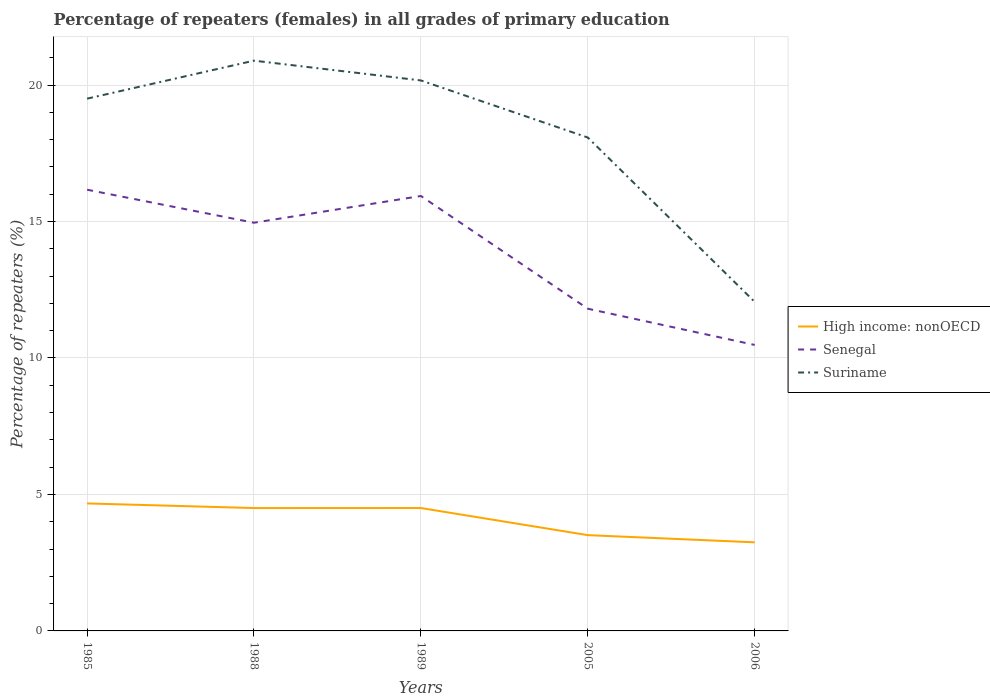How many different coloured lines are there?
Give a very brief answer. 3. Is the number of lines equal to the number of legend labels?
Make the answer very short. Yes. Across all years, what is the maximum percentage of repeaters (females) in Suriname?
Offer a terse response. 12.06. What is the total percentage of repeaters (females) in Senegal in the graph?
Provide a short and direct response. 0.23. What is the difference between the highest and the second highest percentage of repeaters (females) in High income: nonOECD?
Make the answer very short. 1.42. Is the percentage of repeaters (females) in Senegal strictly greater than the percentage of repeaters (females) in High income: nonOECD over the years?
Your response must be concise. No. How many lines are there?
Offer a very short reply. 3. How many years are there in the graph?
Your response must be concise. 5. What is the difference between two consecutive major ticks on the Y-axis?
Your response must be concise. 5. Are the values on the major ticks of Y-axis written in scientific E-notation?
Your response must be concise. No. How are the legend labels stacked?
Give a very brief answer. Vertical. What is the title of the graph?
Your answer should be compact. Percentage of repeaters (females) in all grades of primary education. Does "Belgium" appear as one of the legend labels in the graph?
Make the answer very short. No. What is the label or title of the Y-axis?
Your answer should be compact. Percentage of repeaters (%). What is the Percentage of repeaters (%) in High income: nonOECD in 1985?
Ensure brevity in your answer.  4.67. What is the Percentage of repeaters (%) of Senegal in 1985?
Keep it short and to the point. 16.17. What is the Percentage of repeaters (%) of Suriname in 1985?
Provide a short and direct response. 19.5. What is the Percentage of repeaters (%) of High income: nonOECD in 1988?
Offer a terse response. 4.5. What is the Percentage of repeaters (%) of Senegal in 1988?
Keep it short and to the point. 14.96. What is the Percentage of repeaters (%) in Suriname in 1988?
Provide a succinct answer. 20.89. What is the Percentage of repeaters (%) of High income: nonOECD in 1989?
Provide a short and direct response. 4.5. What is the Percentage of repeaters (%) of Senegal in 1989?
Keep it short and to the point. 15.94. What is the Percentage of repeaters (%) of Suriname in 1989?
Give a very brief answer. 20.17. What is the Percentage of repeaters (%) of High income: nonOECD in 2005?
Keep it short and to the point. 3.51. What is the Percentage of repeaters (%) of Senegal in 2005?
Ensure brevity in your answer.  11.81. What is the Percentage of repeaters (%) of Suriname in 2005?
Your answer should be very brief. 18.08. What is the Percentage of repeaters (%) in High income: nonOECD in 2006?
Give a very brief answer. 3.25. What is the Percentage of repeaters (%) in Senegal in 2006?
Offer a very short reply. 10.48. What is the Percentage of repeaters (%) in Suriname in 2006?
Provide a short and direct response. 12.06. Across all years, what is the maximum Percentage of repeaters (%) in High income: nonOECD?
Your answer should be compact. 4.67. Across all years, what is the maximum Percentage of repeaters (%) in Senegal?
Your response must be concise. 16.17. Across all years, what is the maximum Percentage of repeaters (%) in Suriname?
Your answer should be compact. 20.89. Across all years, what is the minimum Percentage of repeaters (%) of High income: nonOECD?
Your response must be concise. 3.25. Across all years, what is the minimum Percentage of repeaters (%) in Senegal?
Your answer should be very brief. 10.48. Across all years, what is the minimum Percentage of repeaters (%) in Suriname?
Provide a succinct answer. 12.06. What is the total Percentage of repeaters (%) in High income: nonOECD in the graph?
Offer a terse response. 20.43. What is the total Percentage of repeaters (%) of Senegal in the graph?
Make the answer very short. 69.34. What is the total Percentage of repeaters (%) of Suriname in the graph?
Your answer should be very brief. 90.7. What is the difference between the Percentage of repeaters (%) in High income: nonOECD in 1985 and that in 1988?
Provide a succinct answer. 0.17. What is the difference between the Percentage of repeaters (%) in Senegal in 1985 and that in 1988?
Your answer should be compact. 1.21. What is the difference between the Percentage of repeaters (%) of Suriname in 1985 and that in 1988?
Ensure brevity in your answer.  -1.39. What is the difference between the Percentage of repeaters (%) of High income: nonOECD in 1985 and that in 1989?
Your answer should be compact. 0.17. What is the difference between the Percentage of repeaters (%) in Senegal in 1985 and that in 1989?
Give a very brief answer. 0.23. What is the difference between the Percentage of repeaters (%) in Suriname in 1985 and that in 1989?
Provide a succinct answer. -0.67. What is the difference between the Percentage of repeaters (%) in High income: nonOECD in 1985 and that in 2005?
Offer a very short reply. 1.16. What is the difference between the Percentage of repeaters (%) of Senegal in 1985 and that in 2005?
Give a very brief answer. 4.36. What is the difference between the Percentage of repeaters (%) of Suriname in 1985 and that in 2005?
Provide a succinct answer. 1.42. What is the difference between the Percentage of repeaters (%) of High income: nonOECD in 1985 and that in 2006?
Make the answer very short. 1.42. What is the difference between the Percentage of repeaters (%) in Senegal in 1985 and that in 2006?
Make the answer very short. 5.69. What is the difference between the Percentage of repeaters (%) in Suriname in 1985 and that in 2006?
Offer a very short reply. 7.45. What is the difference between the Percentage of repeaters (%) of High income: nonOECD in 1988 and that in 1989?
Offer a terse response. -0. What is the difference between the Percentage of repeaters (%) of Senegal in 1988 and that in 1989?
Your answer should be compact. -0.98. What is the difference between the Percentage of repeaters (%) in Suriname in 1988 and that in 1989?
Give a very brief answer. 0.72. What is the difference between the Percentage of repeaters (%) in High income: nonOECD in 1988 and that in 2005?
Offer a very short reply. 0.99. What is the difference between the Percentage of repeaters (%) of Senegal in 1988 and that in 2005?
Offer a very short reply. 3.15. What is the difference between the Percentage of repeaters (%) of Suriname in 1988 and that in 2005?
Provide a short and direct response. 2.82. What is the difference between the Percentage of repeaters (%) in High income: nonOECD in 1988 and that in 2006?
Give a very brief answer. 1.26. What is the difference between the Percentage of repeaters (%) in Senegal in 1988 and that in 2006?
Provide a short and direct response. 4.48. What is the difference between the Percentage of repeaters (%) in Suriname in 1988 and that in 2006?
Provide a succinct answer. 8.84. What is the difference between the Percentage of repeaters (%) in High income: nonOECD in 1989 and that in 2005?
Offer a very short reply. 0.99. What is the difference between the Percentage of repeaters (%) in Senegal in 1989 and that in 2005?
Your response must be concise. 4.13. What is the difference between the Percentage of repeaters (%) of Suriname in 1989 and that in 2005?
Offer a terse response. 2.09. What is the difference between the Percentage of repeaters (%) in High income: nonOECD in 1989 and that in 2006?
Ensure brevity in your answer.  1.26. What is the difference between the Percentage of repeaters (%) of Senegal in 1989 and that in 2006?
Ensure brevity in your answer.  5.46. What is the difference between the Percentage of repeaters (%) of Suriname in 1989 and that in 2006?
Your response must be concise. 8.11. What is the difference between the Percentage of repeaters (%) of High income: nonOECD in 2005 and that in 2006?
Provide a short and direct response. 0.26. What is the difference between the Percentage of repeaters (%) in Senegal in 2005 and that in 2006?
Ensure brevity in your answer.  1.33. What is the difference between the Percentage of repeaters (%) in Suriname in 2005 and that in 2006?
Make the answer very short. 6.02. What is the difference between the Percentage of repeaters (%) in High income: nonOECD in 1985 and the Percentage of repeaters (%) in Senegal in 1988?
Make the answer very short. -10.29. What is the difference between the Percentage of repeaters (%) in High income: nonOECD in 1985 and the Percentage of repeaters (%) in Suriname in 1988?
Keep it short and to the point. -16.22. What is the difference between the Percentage of repeaters (%) of Senegal in 1985 and the Percentage of repeaters (%) of Suriname in 1988?
Provide a short and direct response. -4.73. What is the difference between the Percentage of repeaters (%) in High income: nonOECD in 1985 and the Percentage of repeaters (%) in Senegal in 1989?
Offer a terse response. -11.27. What is the difference between the Percentage of repeaters (%) in High income: nonOECD in 1985 and the Percentage of repeaters (%) in Suriname in 1989?
Give a very brief answer. -15.5. What is the difference between the Percentage of repeaters (%) in Senegal in 1985 and the Percentage of repeaters (%) in Suriname in 1989?
Make the answer very short. -4. What is the difference between the Percentage of repeaters (%) in High income: nonOECD in 1985 and the Percentage of repeaters (%) in Senegal in 2005?
Offer a very short reply. -7.13. What is the difference between the Percentage of repeaters (%) in High income: nonOECD in 1985 and the Percentage of repeaters (%) in Suriname in 2005?
Give a very brief answer. -13.41. What is the difference between the Percentage of repeaters (%) in Senegal in 1985 and the Percentage of repeaters (%) in Suriname in 2005?
Provide a succinct answer. -1.91. What is the difference between the Percentage of repeaters (%) in High income: nonOECD in 1985 and the Percentage of repeaters (%) in Senegal in 2006?
Your answer should be compact. -5.81. What is the difference between the Percentage of repeaters (%) of High income: nonOECD in 1985 and the Percentage of repeaters (%) of Suriname in 2006?
Offer a terse response. -7.38. What is the difference between the Percentage of repeaters (%) in Senegal in 1985 and the Percentage of repeaters (%) in Suriname in 2006?
Provide a short and direct response. 4.11. What is the difference between the Percentage of repeaters (%) of High income: nonOECD in 1988 and the Percentage of repeaters (%) of Senegal in 1989?
Offer a very short reply. -11.43. What is the difference between the Percentage of repeaters (%) of High income: nonOECD in 1988 and the Percentage of repeaters (%) of Suriname in 1989?
Make the answer very short. -15.67. What is the difference between the Percentage of repeaters (%) in Senegal in 1988 and the Percentage of repeaters (%) in Suriname in 1989?
Provide a succinct answer. -5.21. What is the difference between the Percentage of repeaters (%) in High income: nonOECD in 1988 and the Percentage of repeaters (%) in Senegal in 2005?
Keep it short and to the point. -7.3. What is the difference between the Percentage of repeaters (%) in High income: nonOECD in 1988 and the Percentage of repeaters (%) in Suriname in 2005?
Provide a succinct answer. -13.58. What is the difference between the Percentage of repeaters (%) in Senegal in 1988 and the Percentage of repeaters (%) in Suriname in 2005?
Your answer should be very brief. -3.12. What is the difference between the Percentage of repeaters (%) in High income: nonOECD in 1988 and the Percentage of repeaters (%) in Senegal in 2006?
Keep it short and to the point. -5.98. What is the difference between the Percentage of repeaters (%) in High income: nonOECD in 1988 and the Percentage of repeaters (%) in Suriname in 2006?
Your response must be concise. -7.55. What is the difference between the Percentage of repeaters (%) of Senegal in 1988 and the Percentage of repeaters (%) of Suriname in 2006?
Provide a succinct answer. 2.9. What is the difference between the Percentage of repeaters (%) in High income: nonOECD in 1989 and the Percentage of repeaters (%) in Senegal in 2005?
Offer a terse response. -7.3. What is the difference between the Percentage of repeaters (%) in High income: nonOECD in 1989 and the Percentage of repeaters (%) in Suriname in 2005?
Give a very brief answer. -13.58. What is the difference between the Percentage of repeaters (%) in Senegal in 1989 and the Percentage of repeaters (%) in Suriname in 2005?
Provide a short and direct response. -2.14. What is the difference between the Percentage of repeaters (%) of High income: nonOECD in 1989 and the Percentage of repeaters (%) of Senegal in 2006?
Keep it short and to the point. -5.98. What is the difference between the Percentage of repeaters (%) in High income: nonOECD in 1989 and the Percentage of repeaters (%) in Suriname in 2006?
Give a very brief answer. -7.55. What is the difference between the Percentage of repeaters (%) in Senegal in 1989 and the Percentage of repeaters (%) in Suriname in 2006?
Your answer should be very brief. 3.88. What is the difference between the Percentage of repeaters (%) of High income: nonOECD in 2005 and the Percentage of repeaters (%) of Senegal in 2006?
Ensure brevity in your answer.  -6.97. What is the difference between the Percentage of repeaters (%) of High income: nonOECD in 2005 and the Percentage of repeaters (%) of Suriname in 2006?
Offer a terse response. -8.55. What is the difference between the Percentage of repeaters (%) of Senegal in 2005 and the Percentage of repeaters (%) of Suriname in 2006?
Your response must be concise. -0.25. What is the average Percentage of repeaters (%) of High income: nonOECD per year?
Give a very brief answer. 4.09. What is the average Percentage of repeaters (%) of Senegal per year?
Offer a terse response. 13.87. What is the average Percentage of repeaters (%) in Suriname per year?
Your response must be concise. 18.14. In the year 1985, what is the difference between the Percentage of repeaters (%) in High income: nonOECD and Percentage of repeaters (%) in Senegal?
Provide a short and direct response. -11.5. In the year 1985, what is the difference between the Percentage of repeaters (%) of High income: nonOECD and Percentage of repeaters (%) of Suriname?
Your answer should be very brief. -14.83. In the year 1985, what is the difference between the Percentage of repeaters (%) of Senegal and Percentage of repeaters (%) of Suriname?
Your response must be concise. -3.34. In the year 1988, what is the difference between the Percentage of repeaters (%) of High income: nonOECD and Percentage of repeaters (%) of Senegal?
Provide a short and direct response. -10.45. In the year 1988, what is the difference between the Percentage of repeaters (%) in High income: nonOECD and Percentage of repeaters (%) in Suriname?
Your answer should be very brief. -16.39. In the year 1988, what is the difference between the Percentage of repeaters (%) of Senegal and Percentage of repeaters (%) of Suriname?
Provide a succinct answer. -5.94. In the year 1989, what is the difference between the Percentage of repeaters (%) of High income: nonOECD and Percentage of repeaters (%) of Senegal?
Ensure brevity in your answer.  -11.43. In the year 1989, what is the difference between the Percentage of repeaters (%) of High income: nonOECD and Percentage of repeaters (%) of Suriname?
Ensure brevity in your answer.  -15.67. In the year 1989, what is the difference between the Percentage of repeaters (%) in Senegal and Percentage of repeaters (%) in Suriname?
Your answer should be compact. -4.23. In the year 2005, what is the difference between the Percentage of repeaters (%) of High income: nonOECD and Percentage of repeaters (%) of Senegal?
Ensure brevity in your answer.  -8.3. In the year 2005, what is the difference between the Percentage of repeaters (%) in High income: nonOECD and Percentage of repeaters (%) in Suriname?
Make the answer very short. -14.57. In the year 2005, what is the difference between the Percentage of repeaters (%) of Senegal and Percentage of repeaters (%) of Suriname?
Your response must be concise. -6.27. In the year 2006, what is the difference between the Percentage of repeaters (%) of High income: nonOECD and Percentage of repeaters (%) of Senegal?
Offer a terse response. -7.23. In the year 2006, what is the difference between the Percentage of repeaters (%) in High income: nonOECD and Percentage of repeaters (%) in Suriname?
Keep it short and to the point. -8.81. In the year 2006, what is the difference between the Percentage of repeaters (%) of Senegal and Percentage of repeaters (%) of Suriname?
Your answer should be compact. -1.58. What is the ratio of the Percentage of repeaters (%) in High income: nonOECD in 1985 to that in 1988?
Your answer should be compact. 1.04. What is the ratio of the Percentage of repeaters (%) in Senegal in 1985 to that in 1988?
Ensure brevity in your answer.  1.08. What is the ratio of the Percentage of repeaters (%) of Suriname in 1985 to that in 1988?
Your response must be concise. 0.93. What is the ratio of the Percentage of repeaters (%) of High income: nonOECD in 1985 to that in 1989?
Give a very brief answer. 1.04. What is the ratio of the Percentage of repeaters (%) of Senegal in 1985 to that in 1989?
Provide a succinct answer. 1.01. What is the ratio of the Percentage of repeaters (%) of Suriname in 1985 to that in 1989?
Ensure brevity in your answer.  0.97. What is the ratio of the Percentage of repeaters (%) in High income: nonOECD in 1985 to that in 2005?
Ensure brevity in your answer.  1.33. What is the ratio of the Percentage of repeaters (%) in Senegal in 1985 to that in 2005?
Your answer should be very brief. 1.37. What is the ratio of the Percentage of repeaters (%) of Suriname in 1985 to that in 2005?
Your response must be concise. 1.08. What is the ratio of the Percentage of repeaters (%) of High income: nonOECD in 1985 to that in 2006?
Offer a very short reply. 1.44. What is the ratio of the Percentage of repeaters (%) in Senegal in 1985 to that in 2006?
Provide a short and direct response. 1.54. What is the ratio of the Percentage of repeaters (%) of Suriname in 1985 to that in 2006?
Your answer should be compact. 1.62. What is the ratio of the Percentage of repeaters (%) in Senegal in 1988 to that in 1989?
Offer a very short reply. 0.94. What is the ratio of the Percentage of repeaters (%) in Suriname in 1988 to that in 1989?
Make the answer very short. 1.04. What is the ratio of the Percentage of repeaters (%) in High income: nonOECD in 1988 to that in 2005?
Keep it short and to the point. 1.28. What is the ratio of the Percentage of repeaters (%) in Senegal in 1988 to that in 2005?
Provide a succinct answer. 1.27. What is the ratio of the Percentage of repeaters (%) in Suriname in 1988 to that in 2005?
Your answer should be very brief. 1.16. What is the ratio of the Percentage of repeaters (%) of High income: nonOECD in 1988 to that in 2006?
Make the answer very short. 1.39. What is the ratio of the Percentage of repeaters (%) of Senegal in 1988 to that in 2006?
Offer a very short reply. 1.43. What is the ratio of the Percentage of repeaters (%) in Suriname in 1988 to that in 2006?
Offer a very short reply. 1.73. What is the ratio of the Percentage of repeaters (%) in High income: nonOECD in 1989 to that in 2005?
Give a very brief answer. 1.28. What is the ratio of the Percentage of repeaters (%) of Senegal in 1989 to that in 2005?
Make the answer very short. 1.35. What is the ratio of the Percentage of repeaters (%) in Suriname in 1989 to that in 2005?
Offer a terse response. 1.12. What is the ratio of the Percentage of repeaters (%) of High income: nonOECD in 1989 to that in 2006?
Make the answer very short. 1.39. What is the ratio of the Percentage of repeaters (%) in Senegal in 1989 to that in 2006?
Ensure brevity in your answer.  1.52. What is the ratio of the Percentage of repeaters (%) of Suriname in 1989 to that in 2006?
Keep it short and to the point. 1.67. What is the ratio of the Percentage of repeaters (%) in High income: nonOECD in 2005 to that in 2006?
Make the answer very short. 1.08. What is the ratio of the Percentage of repeaters (%) of Senegal in 2005 to that in 2006?
Make the answer very short. 1.13. What is the ratio of the Percentage of repeaters (%) of Suriname in 2005 to that in 2006?
Your response must be concise. 1.5. What is the difference between the highest and the second highest Percentage of repeaters (%) of High income: nonOECD?
Make the answer very short. 0.17. What is the difference between the highest and the second highest Percentage of repeaters (%) of Senegal?
Your answer should be compact. 0.23. What is the difference between the highest and the second highest Percentage of repeaters (%) in Suriname?
Offer a terse response. 0.72. What is the difference between the highest and the lowest Percentage of repeaters (%) of High income: nonOECD?
Give a very brief answer. 1.42. What is the difference between the highest and the lowest Percentage of repeaters (%) of Senegal?
Provide a short and direct response. 5.69. What is the difference between the highest and the lowest Percentage of repeaters (%) in Suriname?
Your response must be concise. 8.84. 